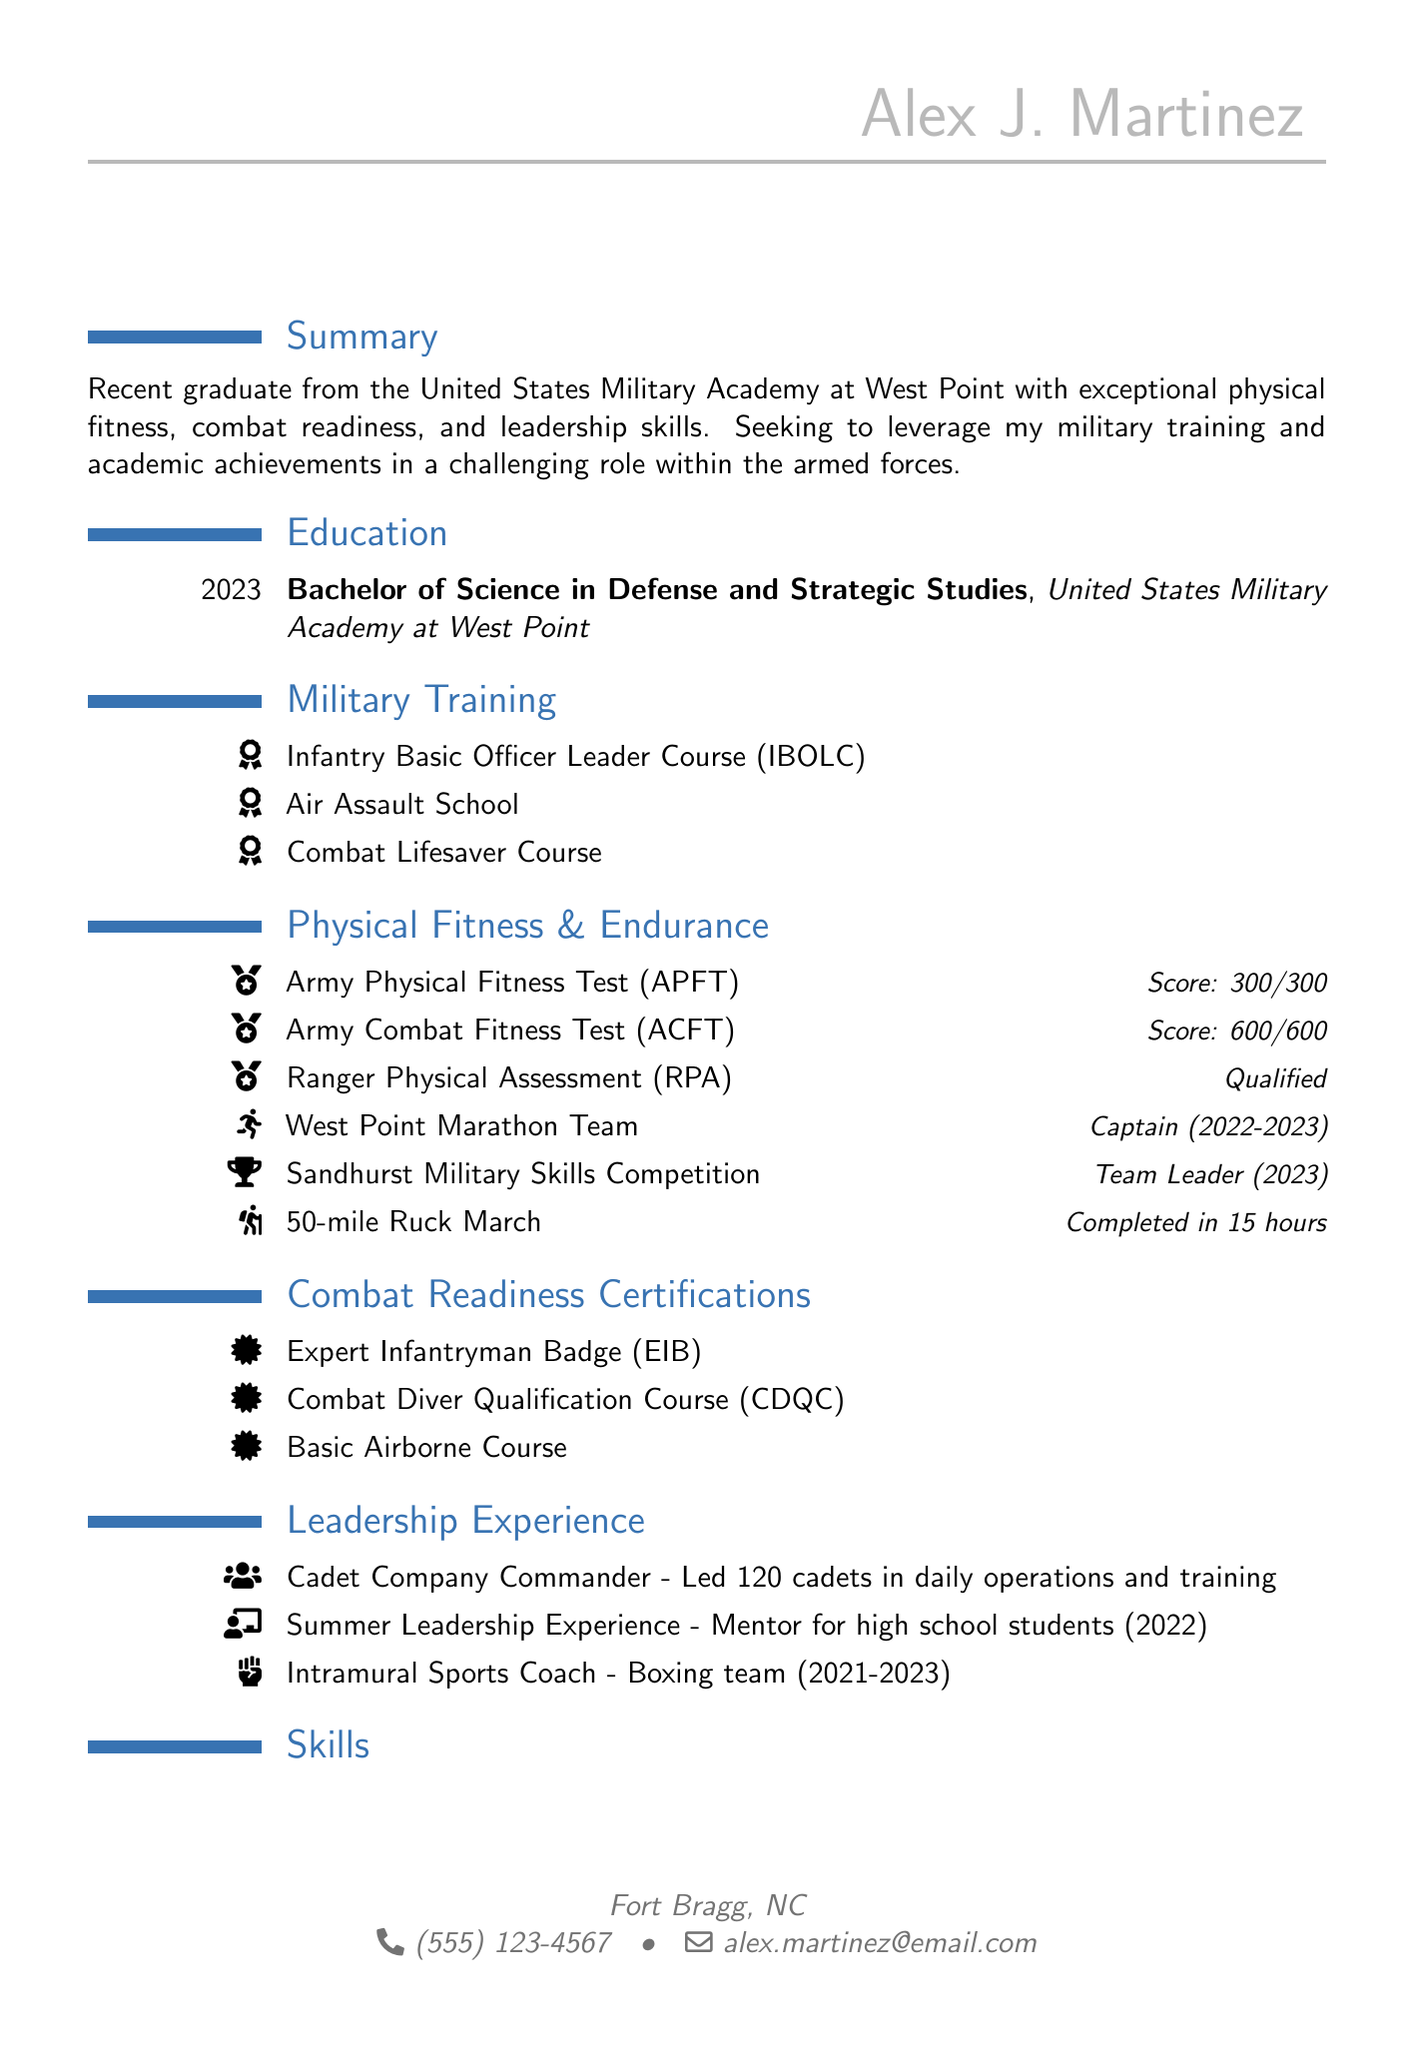what is the name of the individual? The document provides the full name at the top, which is Alex J. Martinez.
Answer: Alex J. Martinez what degree did Alex J. Martinez earn? The degree information is listed under the education section, specifying a Bachelor of Science in Defense and Strategic Studies.
Answer: Bachelor of Science in Defense and Strategic Studies what is the score on the Army Combat Fitness Test? The score for the Army Combat Fitness Test is mentioned in the physical fitness section as 600/600.
Answer: 600/600 how many cadets did Alex lead as a Company Commander? The leadership experience section specifies that Alex led 120 cadets in daily operations and training.
Answer: 120 which course qualifies for the Expert Infantryman Badge? The combat readiness certifications section includes the Expert Infantryman Badge, which is a specific qualification.
Answer: Expert Infantryman Badge who was the captain of the West Point Marathon Team? The document states that Alex J. Martinez held the position of captain for the West Point Marathon Team.
Answer: Alex J. Martinez in which year did Alex graduate from the United States Military Academy at West Point? The graduation year is mentioned in the education section, which is 2023.
Answer: 2023 what is one skill listed under skills? The skills section lists multiple skills; one of them is land navigation.
Answer: Land navigation 